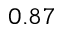<formula> <loc_0><loc_0><loc_500><loc_500>0 . 8 7</formula> 